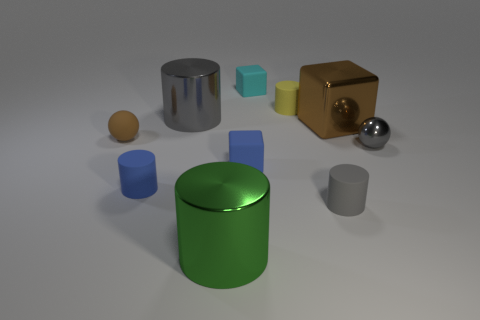What is the texture of the surface beneath the objects? The surface beneath the objects appears to be relatively smooth with a slight texture that could resemble a matte finish. This is indicated by the soft shadows cast by the objects, which hint at a surface that is not completely glossy but has some light-diffusing properties. 